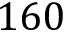<formula> <loc_0><loc_0><loc_500><loc_500>1 6 0</formula> 